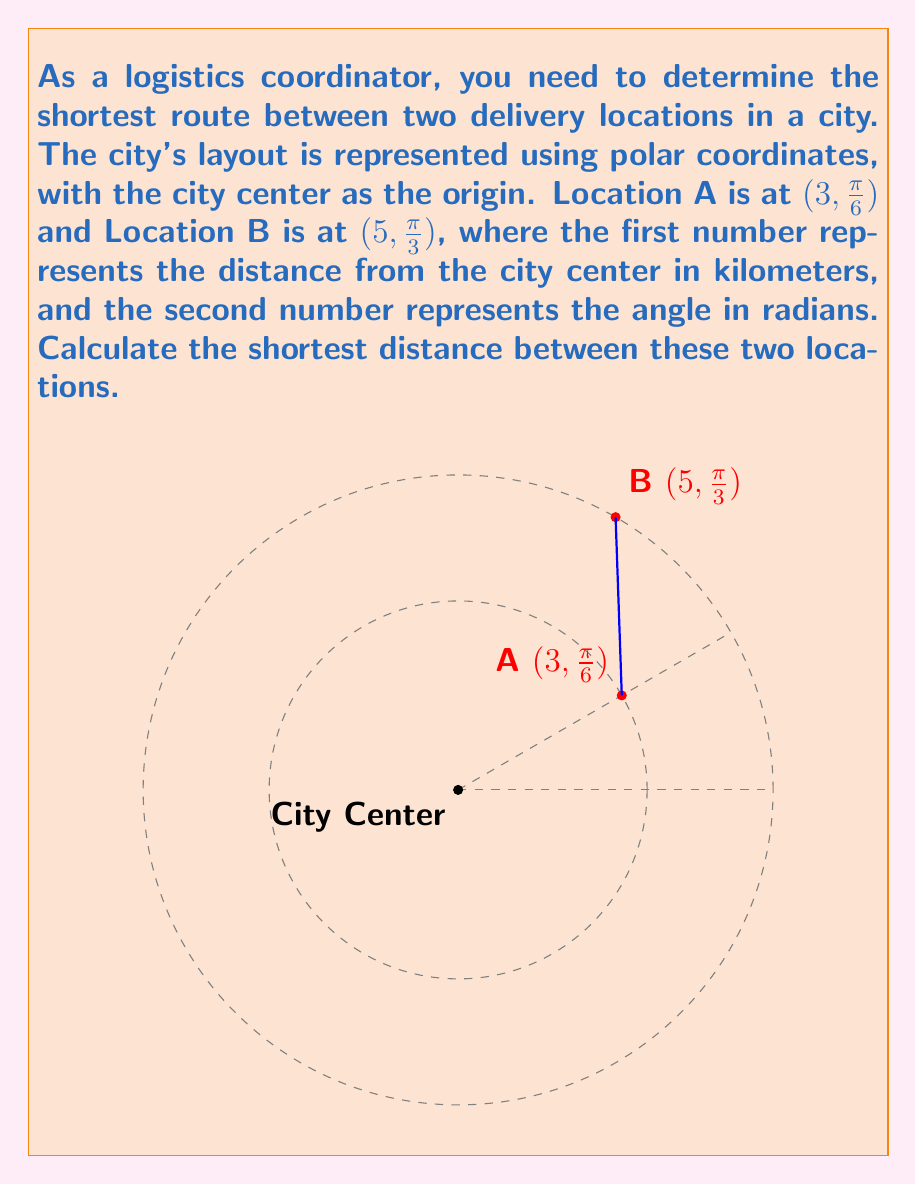Give your solution to this math problem. To find the shortest distance between two points in polar coordinates, we can use the law of cosines. Let's approach this step-by-step:

1) First, we need to identify the given information:
   - Point A: $(r_1, \theta_1) = (3, \frac{\pi}{6})$
   - Point B: $(r_2, \theta_2) = (5, \frac{\pi}{3})$

2) The law of cosines for the distance $d$ between two points in polar coordinates is:

   $$d^2 = r_1^2 + r_2^2 - 2r_1r_2 \cos(\theta_2 - \theta_1)$$

3) Let's substitute our values:
   $$d^2 = 3^2 + 5^2 - 2(3)(5) \cos(\frac{\pi}{3} - \frac{\pi}{6})$$

4) Simplify:
   $$d^2 = 9 + 25 - 30 \cos(\frac{\pi}{6})$$

5) We know that $\cos(\frac{\pi}{6}) = \frac{\sqrt{3}}{2}$, so:
   $$d^2 = 34 - 30(\frac{\sqrt{3}}{2})$$

6) Simplify further:
   $$d^2 = 34 - 15\sqrt{3}$$

7) To get $d$, we take the square root of both sides:
   $$d = \sqrt{34 - 15\sqrt{3}}$$

This is the exact answer. If a decimal approximation is needed, we can calculate:
   $$d \approx 2.6458 \text{ km}$$
Answer: $\sqrt{34 - 15\sqrt{3}}$ km 